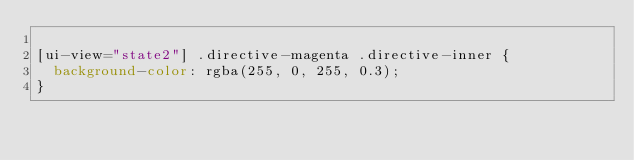<code> <loc_0><loc_0><loc_500><loc_500><_CSS_>
[ui-view="state2"] .directive-magenta .directive-inner {
  background-color: rgba(255, 0, 255, 0.3);
}</code> 